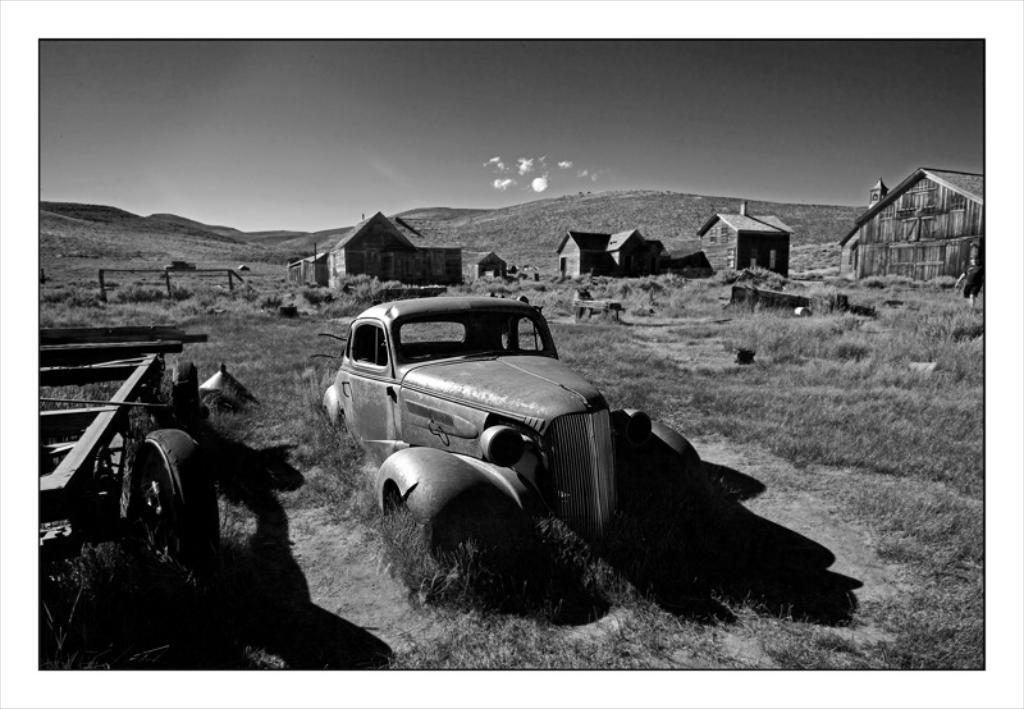What is the main subject of the image? There is a vehicle in the image. What can be seen on the left side of the image? There is a cart on the left side of the image. What type of vegetation is visible on the ground? Some grass is visible on the ground. What can be seen in the background of the image? There are houses and poles in the background of the image. How would you describe the sky in the image? The sky is cloudy in the image. What type of canvas is being used to paint the feeling in the image? There is no canvas or painting present in the image; it features a vehicle, cart, grass, houses, poles, and a cloudy sky. What question is being asked by the vehicle in the image? Vehicles do not ask questions; they are inanimate objects. 